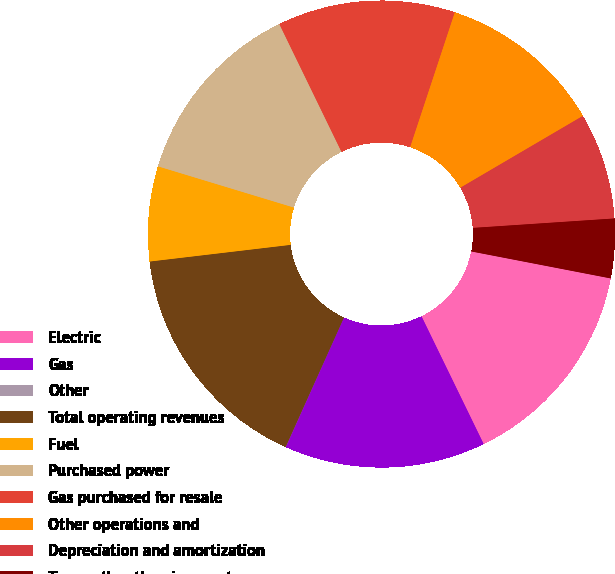Convert chart to OTSL. <chart><loc_0><loc_0><loc_500><loc_500><pie_chart><fcel>Electric<fcel>Gas<fcel>Other<fcel>Total operating revenues<fcel>Fuel<fcel>Purchased power<fcel>Gas purchased for resale<fcel>Other operations and<fcel>Depreciation and amortization<fcel>Taxes other than income taxes<nl><fcel>14.75%<fcel>13.93%<fcel>0.01%<fcel>16.39%<fcel>6.56%<fcel>13.11%<fcel>12.29%<fcel>11.47%<fcel>7.38%<fcel>4.1%<nl></chart> 